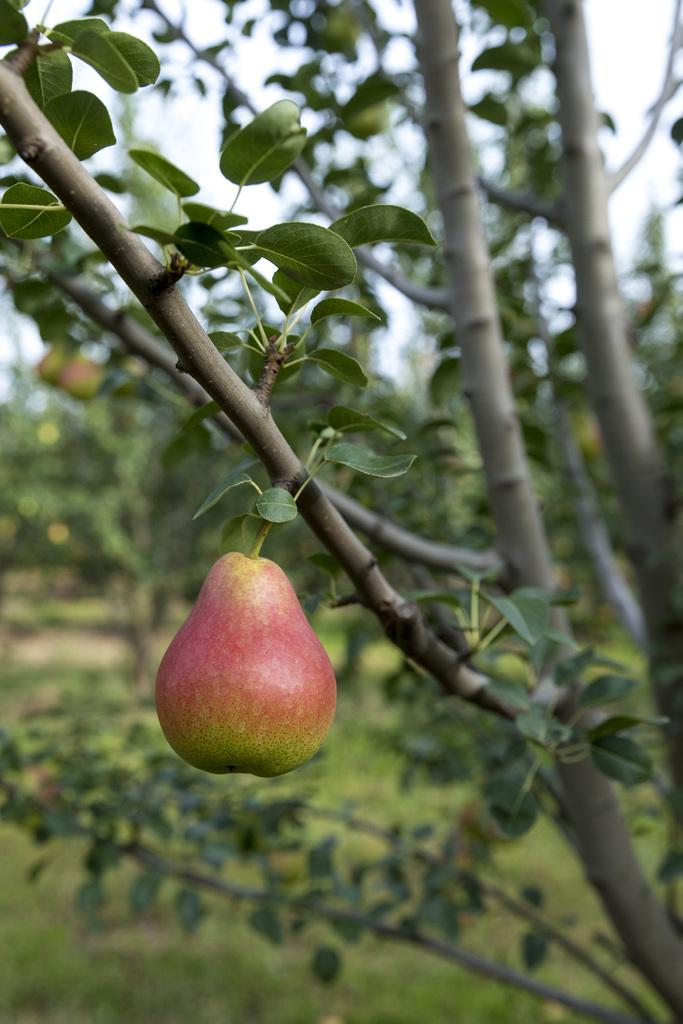What type of fruit is in the image? There is an apple in the image. What is the source of the apple in the image? There is a tree in the image, which is likely the source of the apple. What type of harmony is being played on the calculator in the image? There is no calculator or harmony present in the image; it only features an apple and a tree. 